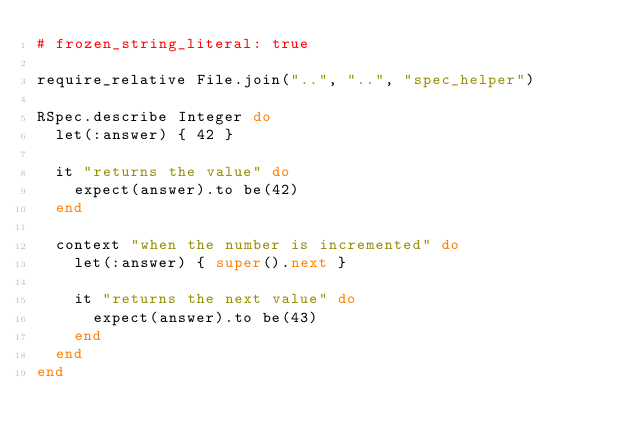Convert code to text. <code><loc_0><loc_0><loc_500><loc_500><_Ruby_># frozen_string_literal: true

require_relative File.join("..", "..", "spec_helper")

RSpec.describe Integer do
  let(:answer) { 42 }

  it "returns the value" do
    expect(answer).to be(42)
  end

  context "when the number is incremented" do
    let(:answer) { super().next }

    it "returns the next value" do
      expect(answer).to be(43)
    end
  end
end
</code> 